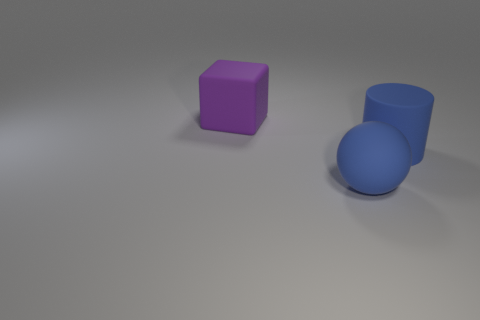What is the color of the thing to the left of the big blue sphere?
Offer a very short reply. Purple. What is the shape of the large purple object?
Offer a very short reply. Cube. There is a big blue rubber object behind the object in front of the blue rubber cylinder; is there a large blue matte object in front of it?
Offer a very short reply. Yes. The rubber thing that is in front of the large blue object that is behind the large blue object in front of the blue matte cylinder is what color?
Your answer should be very brief. Blue. What size is the thing on the left side of the object in front of the large blue cylinder?
Provide a short and direct response. Large. What material is the large cube that is left of the large blue cylinder?
Make the answer very short. Rubber. What is the size of the ball that is made of the same material as the purple cube?
Offer a terse response. Large. What number of other objects are the same shape as the purple rubber thing?
Provide a short and direct response. 0. There is a purple rubber thing; does it have the same shape as the big blue object that is right of the blue matte sphere?
Give a very brief answer. No. What is the shape of the rubber thing that is the same color as the big ball?
Offer a very short reply. Cylinder. 